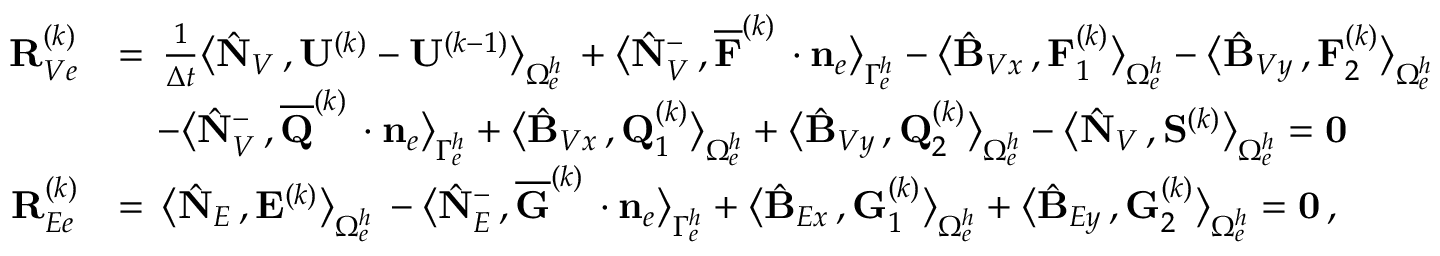Convert formula to latex. <formula><loc_0><loc_0><loc_500><loc_500>\begin{array} { r l } { { R } _ { V e } ^ { ( k ) } } & { = \, \frac { 1 } { \Delta t } \left \langle \hat { N } _ { V } \, , { U } ^ { ( k ) } - { U } ^ { ( k - 1 ) } \right \rangle _ { \Omega _ { e } ^ { h } } \, + \left \langle \hat { N } _ { V } ^ { - } \, , \overline { F } ^ { ( k ) } \, \cdot { n } _ { e } \right \rangle _ { \Gamma _ { e } ^ { h } } - \left \langle \hat { B } _ { V x } \, , { F } _ { 1 } ^ { ( k ) } \right \rangle _ { \Omega _ { e } ^ { h } } - \left \langle \hat { B } _ { V y } \, , { F } _ { 2 } ^ { ( k ) } \right \rangle _ { \Omega _ { e } ^ { h } } } \\ & { \quad - \left \langle \hat { N } _ { V } ^ { - } \, , \overline { Q } ^ { ( k ) } \, \cdot { n } _ { e } \right \rangle _ { \Gamma _ { e } ^ { h } } + \left \langle \hat { B } _ { V x } \, , { Q } _ { 1 } ^ { ( k ) } \right \rangle _ { \Omega _ { e } ^ { h } } + \left \langle \hat { B } _ { V y } \, , { Q } _ { 2 } ^ { ( k ) } \right \rangle _ { \Omega _ { e } ^ { h } } - \left \langle \hat { N } _ { V } \, , { S } ^ { ( k ) } \right \rangle _ { \Omega _ { e } ^ { h } } = { 0 } } \\ { { R } _ { E e } ^ { ( k ) } } & { = \, \left \langle \hat { N } _ { E } \, , { E } ^ { ( k ) } \right \rangle _ { \Omega _ { e } ^ { h } } \, - \left \langle \hat { N } _ { E } ^ { - } \, , \overline { G } ^ { ( k ) } \, \cdot { n } _ { e } \right \rangle _ { \Gamma _ { e } ^ { h } } + \left \langle \hat { B } _ { E x } \, , { G } _ { 1 } ^ { ( k ) } \right \rangle _ { \Omega _ { e } ^ { h } } + \left \langle \hat { B } _ { E y } \, , { G } _ { 2 } ^ { ( k ) } \right \rangle _ { \Omega _ { e } ^ { h } } = { 0 } \, , } \end{array}</formula> 